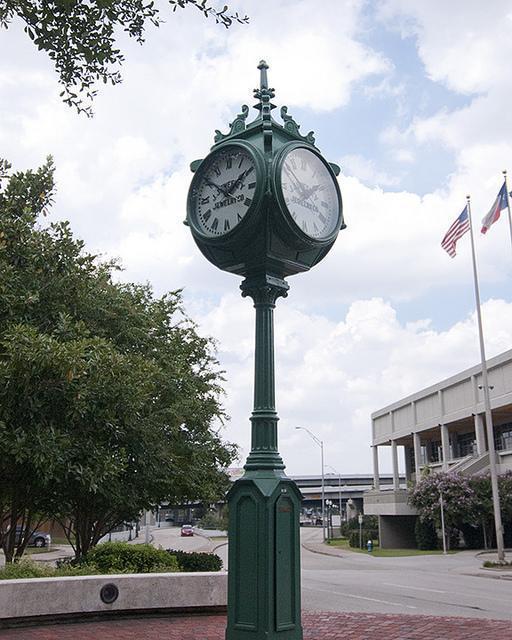How many clocks are shown?
Give a very brief answer. 2. How many clocks are there?
Give a very brief answer. 2. 